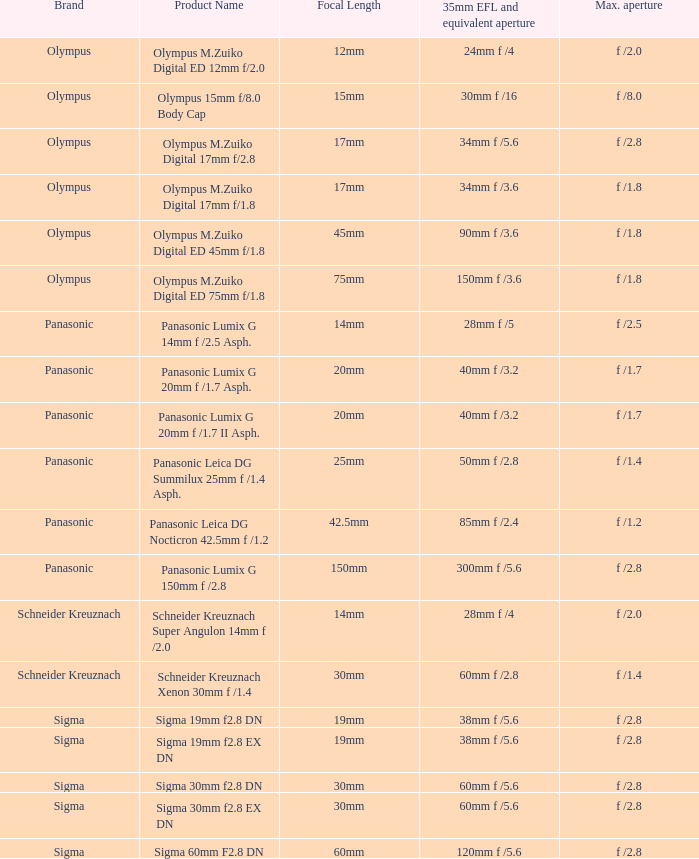8 and a focal length of 30mm? Sigma. 